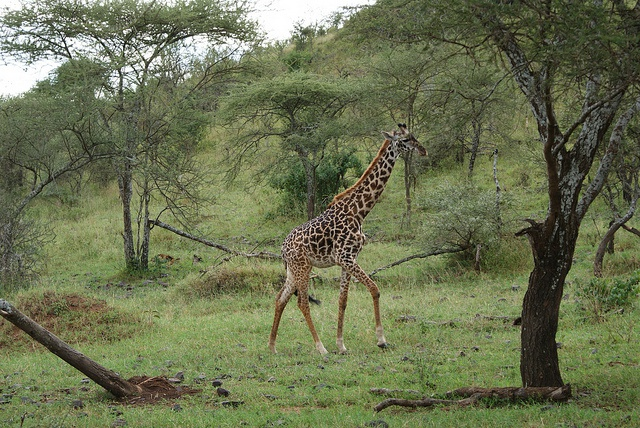Describe the objects in this image and their specific colors. I can see a giraffe in white, black, olive, and gray tones in this image. 